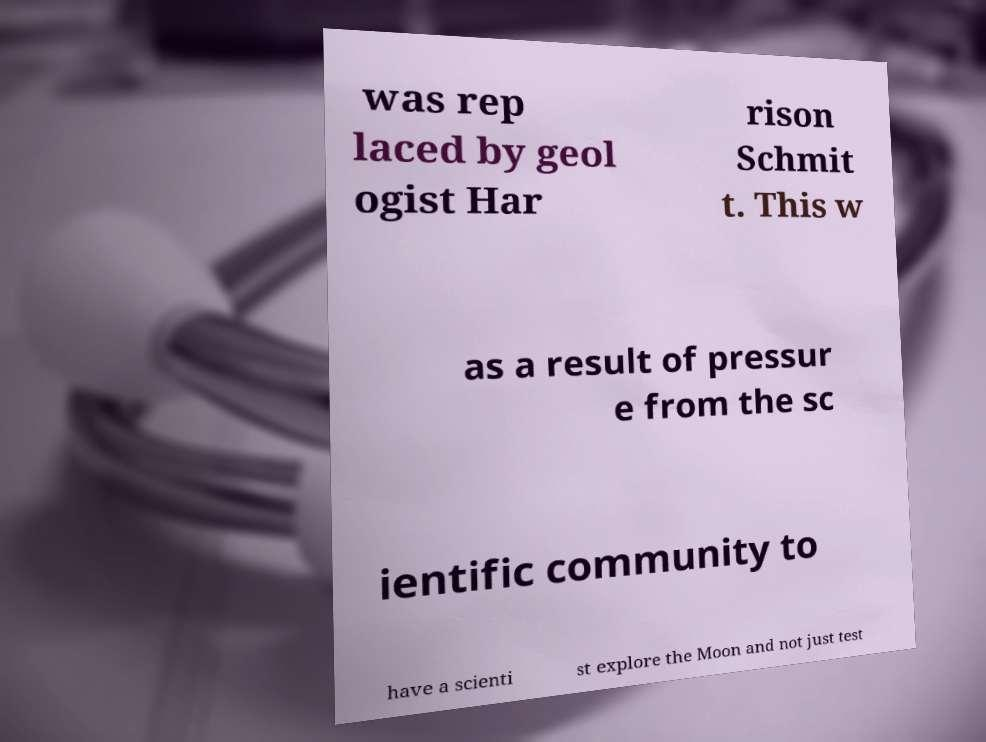Could you assist in decoding the text presented in this image and type it out clearly? was rep laced by geol ogist Har rison Schmit t. This w as a result of pressur e from the sc ientific community to have a scienti st explore the Moon and not just test 